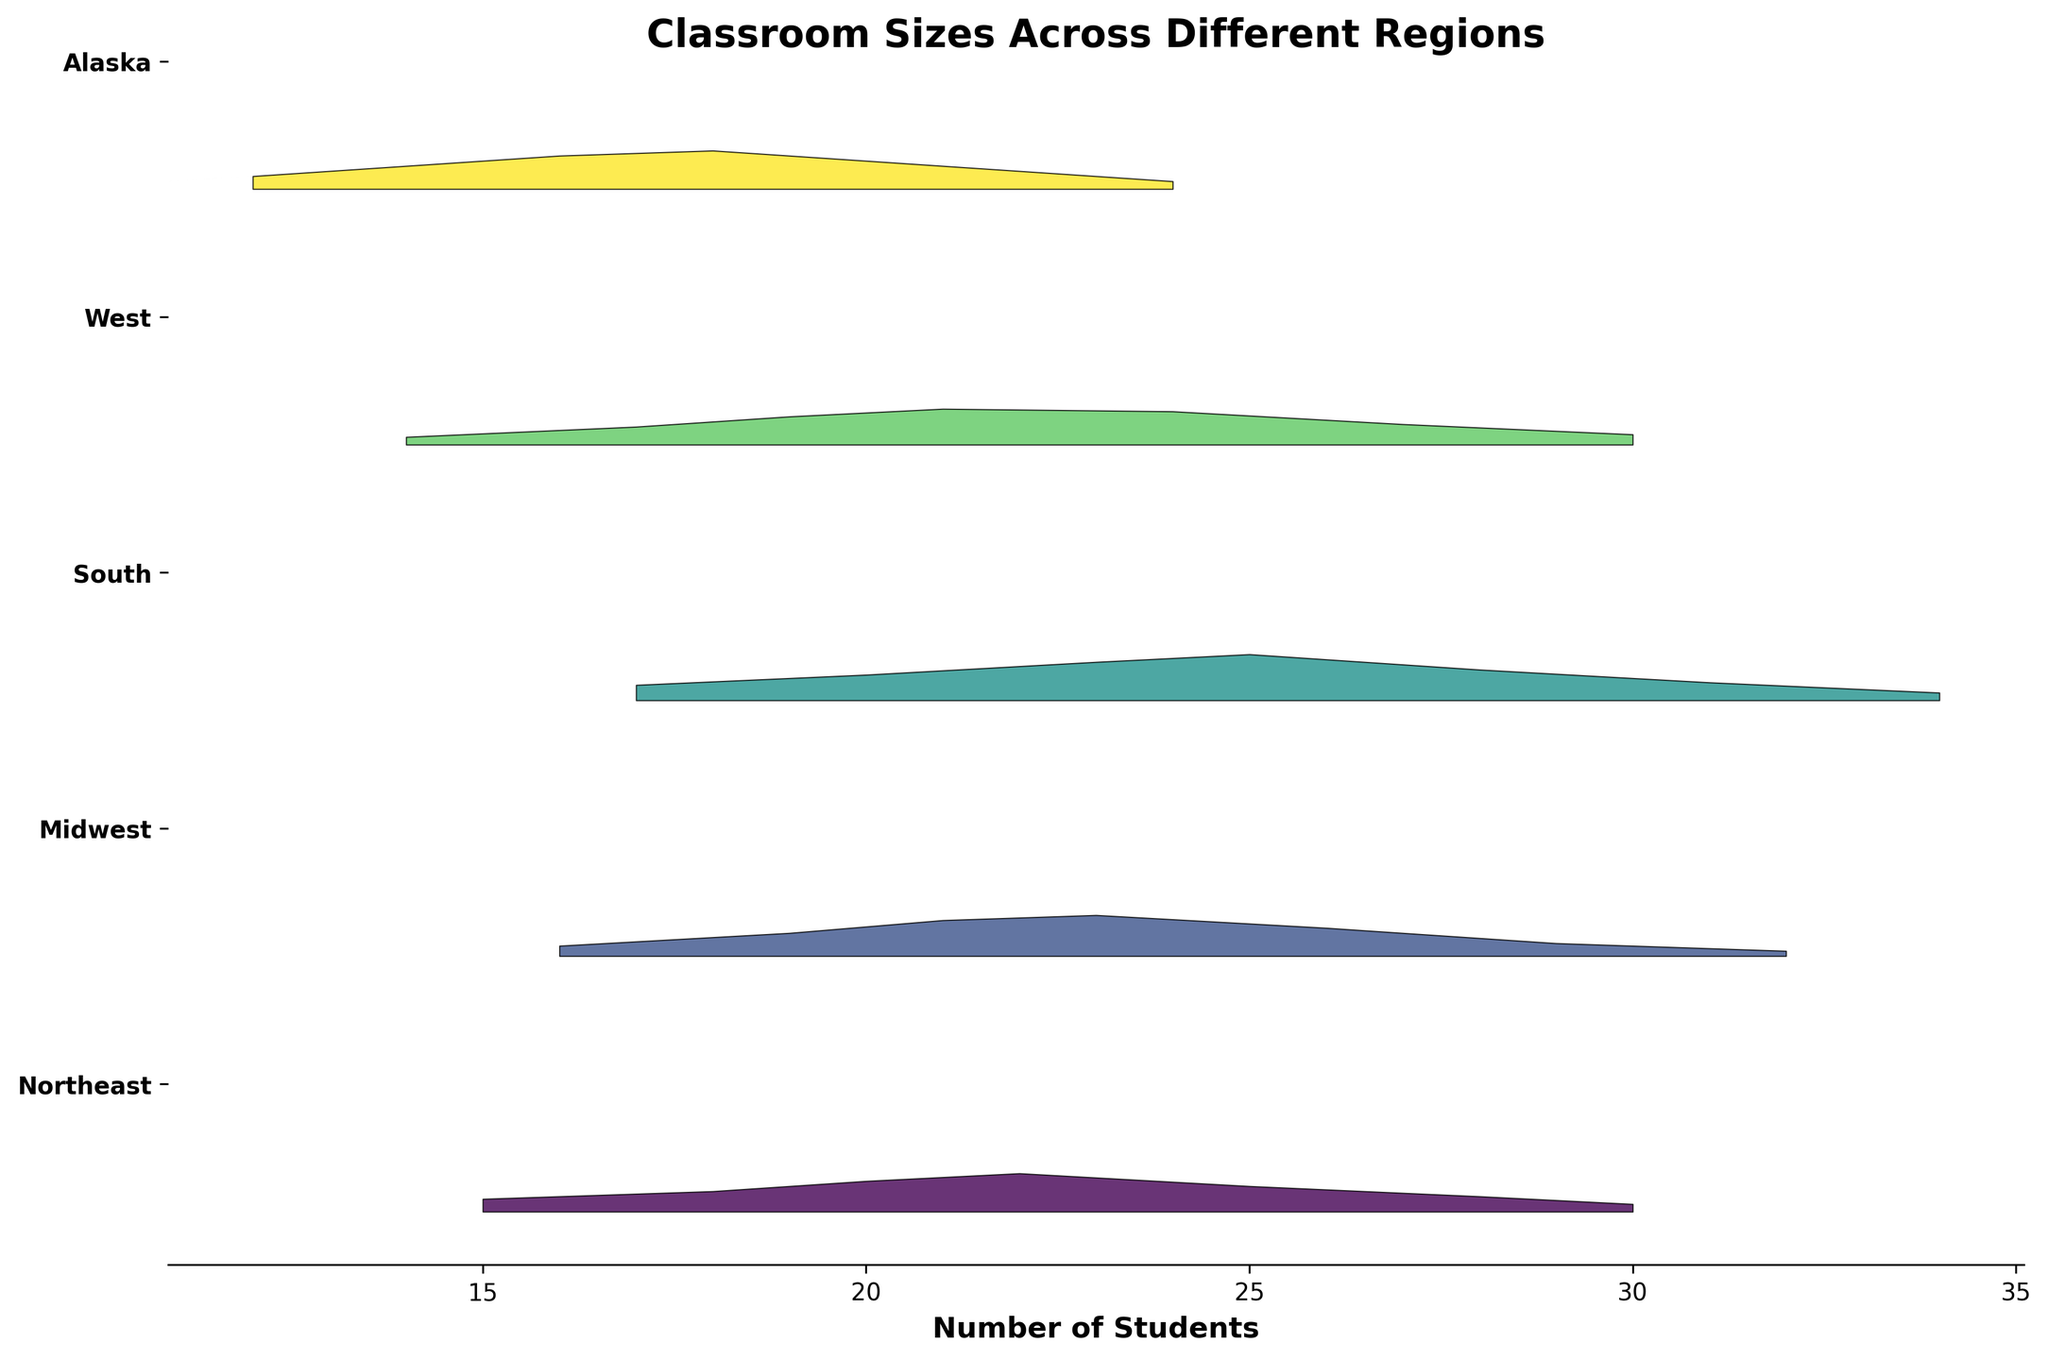What is the title of the figure? The title is usually located at the top of the plot. Here it reads "Classroom Sizes Across Different Regions".
Answer: Classroom Sizes Across Different Regions What is the range of the x-axis? The x-axis represents the number of students, typically shown at the bottom of the plot. The data points range from 12 to 34 students.
Answer: 12 to 34 students Which region has the highest peak density for classroom sizes? The region with the highest density peak is identified by the tallest curve. The South has the highest peak density at 25 students.
Answer: South What is the approximate density value for 20 students in the Midwest? To find this, locate the 20-student point on the x-axis for the Midwest region and observe the corresponding density value, which is about 0.14.
Answer: 0.14 What is the average peak density value across all regions? Identify and sum the peak density values for each region, then divide by the number of regions. The peaks are 0.15 (Northeast), 0.16 (Midwest), 0.18 (South), 0.14 (West), and 0.15 (Alaska). The average value is (0.15 + 0.16 + 0.18 + 0.14 + 0.15) / 5 = 0.156.
Answer: 0.156 Which region has the smallest range in classroom sizes? To determine this, compare the range (difference between maximum and minimum student numbers) for each region. Alaska ranges from 12 to 24 students, a range of 12. This is the smallest range.
Answer: Alaska How many regions have classroom sizes with a peak density above 0.15? From the peak densities: 0.15 (Northeast), 0.16 (Midwest), 0.18 (South), 0.14 (West), 0.15 (Alaska). Only the Midwest and South peaks exceed 0.15.
Answer: 2 Compare the density of classrooms with 25 students in the Northeast and the South. For the Northeast, the density at 25 students is 0.10. For the South, the density at 25 students is 0.18. Therefore, the South has a higher density.
Answer: South What is the difference in the peak density for classroom sizes between the South and the West? The peak density for the South is 0.18 and for the West is 0.14. The difference is 0.18 - 0.14 = 0.04.
Answer: 0.04 